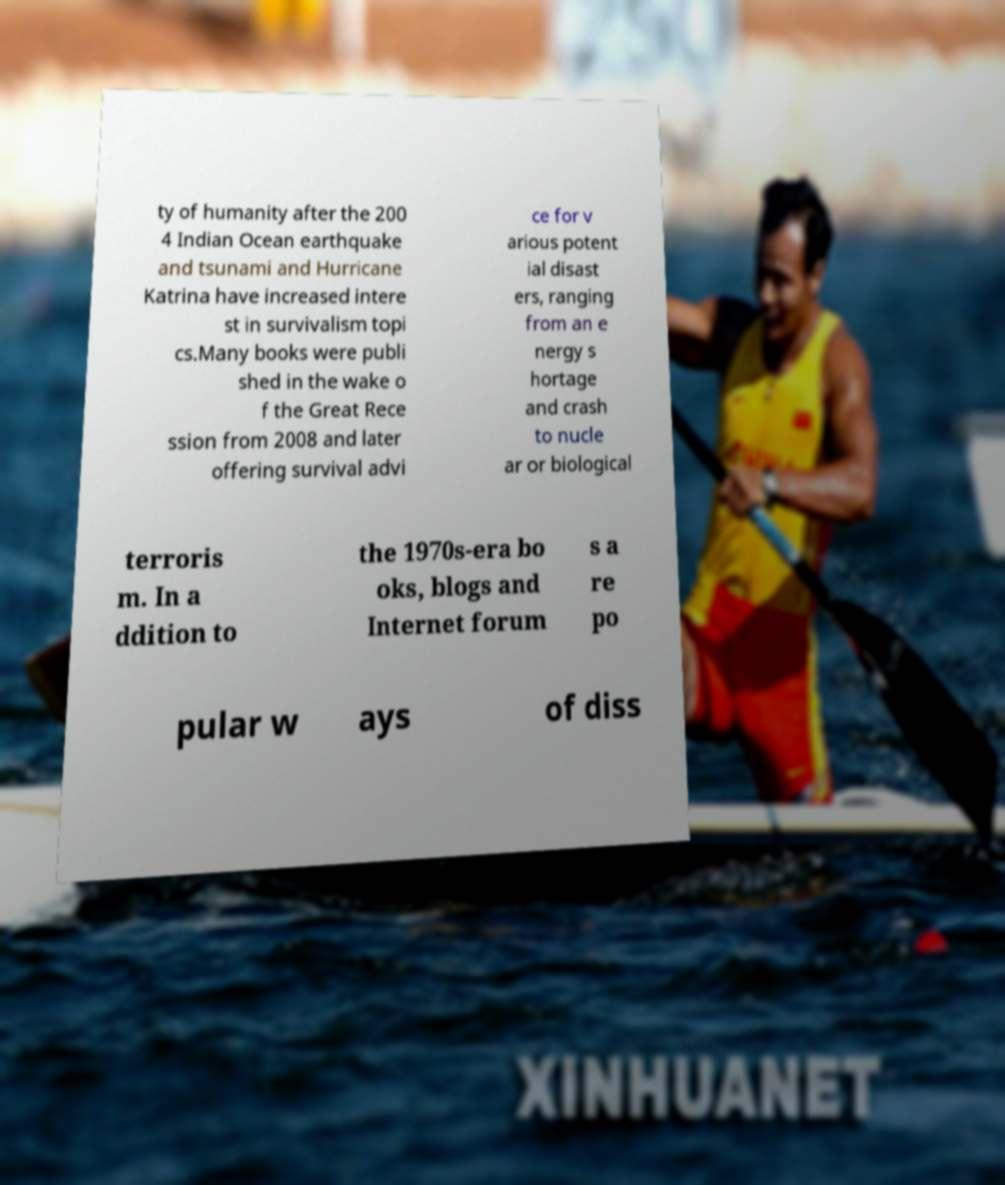There's text embedded in this image that I need extracted. Can you transcribe it verbatim? ty of humanity after the 200 4 Indian Ocean earthquake and tsunami and Hurricane Katrina have increased intere st in survivalism topi cs.Many books were publi shed in the wake o f the Great Rece ssion from 2008 and later offering survival advi ce for v arious potent ial disast ers, ranging from an e nergy s hortage and crash to nucle ar or biological terroris m. In a ddition to the 1970s-era bo oks, blogs and Internet forum s a re po pular w ays of diss 